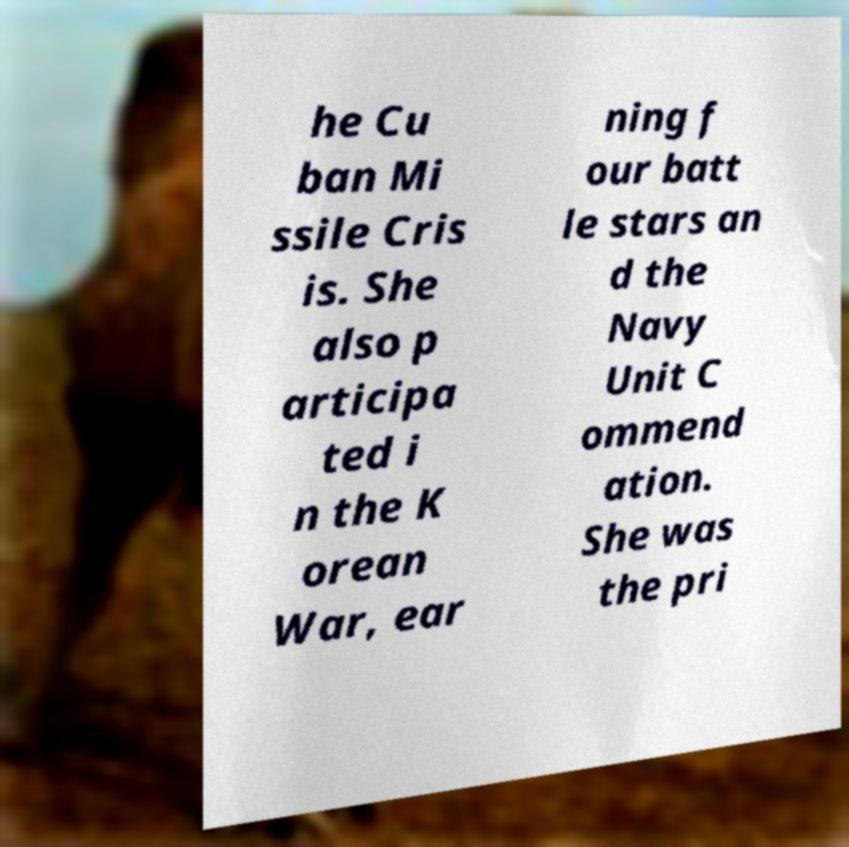Could you assist in decoding the text presented in this image and type it out clearly? he Cu ban Mi ssile Cris is. She also p articipa ted i n the K orean War, ear ning f our batt le stars an d the Navy Unit C ommend ation. She was the pri 